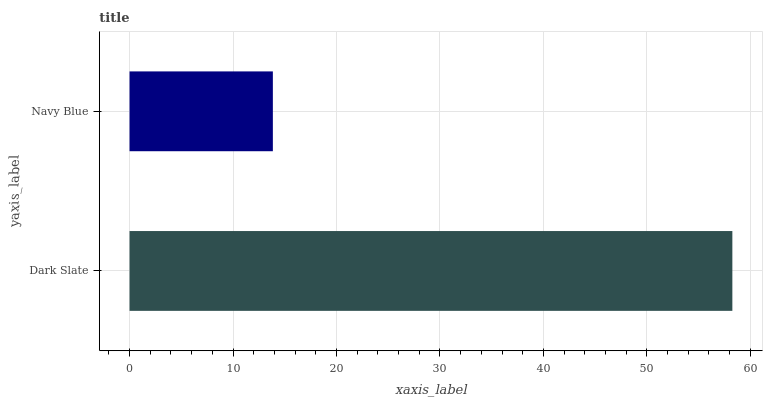Is Navy Blue the minimum?
Answer yes or no. Yes. Is Dark Slate the maximum?
Answer yes or no. Yes. Is Navy Blue the maximum?
Answer yes or no. No. Is Dark Slate greater than Navy Blue?
Answer yes or no. Yes. Is Navy Blue less than Dark Slate?
Answer yes or no. Yes. Is Navy Blue greater than Dark Slate?
Answer yes or no. No. Is Dark Slate less than Navy Blue?
Answer yes or no. No. Is Dark Slate the high median?
Answer yes or no. Yes. Is Navy Blue the low median?
Answer yes or no. Yes. Is Navy Blue the high median?
Answer yes or no. No. Is Dark Slate the low median?
Answer yes or no. No. 